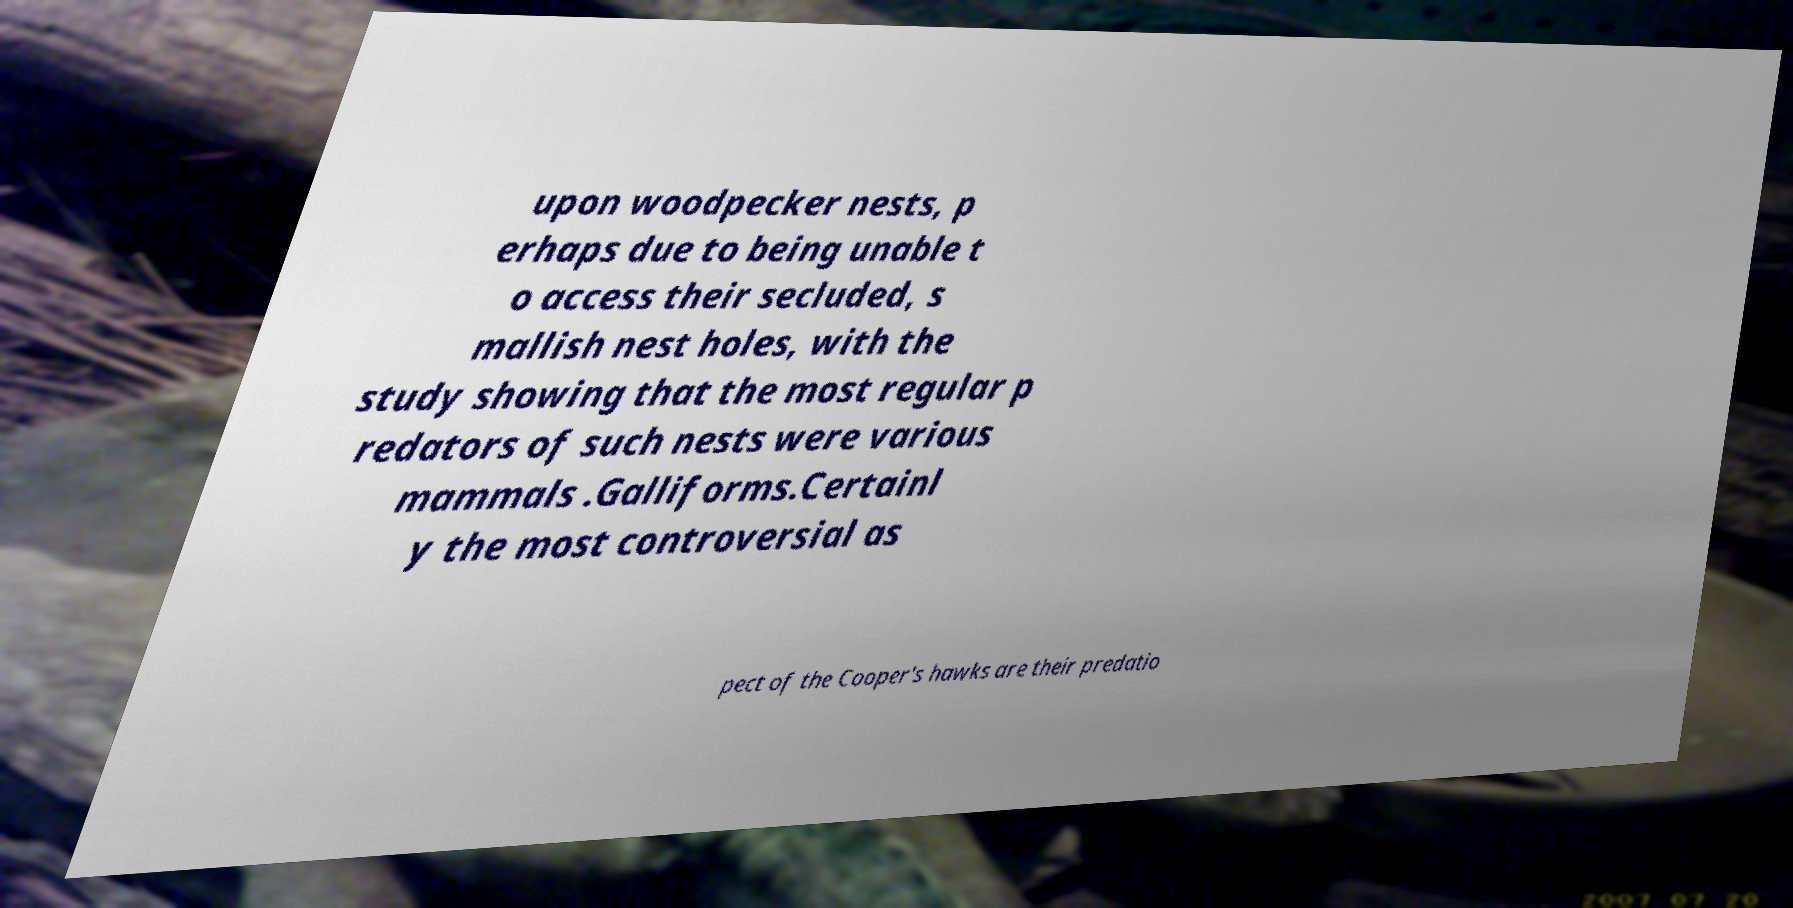Can you accurately transcribe the text from the provided image for me? upon woodpecker nests, p erhaps due to being unable t o access their secluded, s mallish nest holes, with the study showing that the most regular p redators of such nests were various mammals .Galliforms.Certainl y the most controversial as pect of the Cooper's hawks are their predatio 